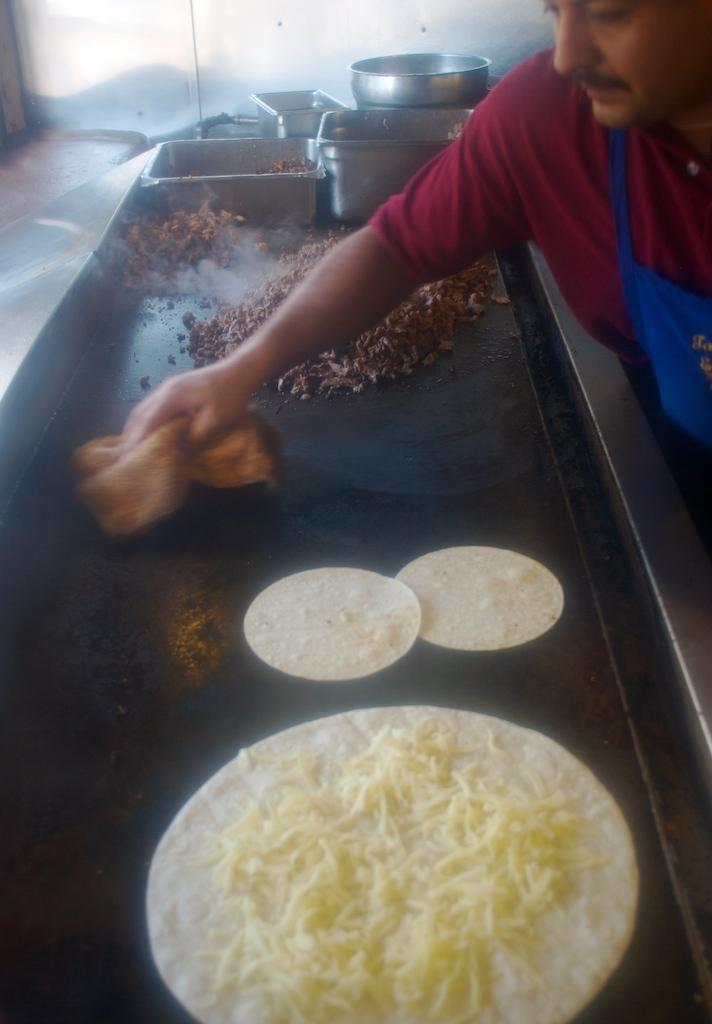Who or what is present in the image? There is a person in the image. What is the person holding in the image? The person is holding a cloth. What can be seen on the surface in the image? There is food on a black surface. What type of objects are related to cooking or food preparation in the image? There are kitchen vessels in the image. What material is visible in the background of the image? There is a steel surface in the background of the image. What type of brick is being used to build the person's brain in the image? There is no brick or reference to a brain in the image; it features a person holding a cloth and food on a black surface. 